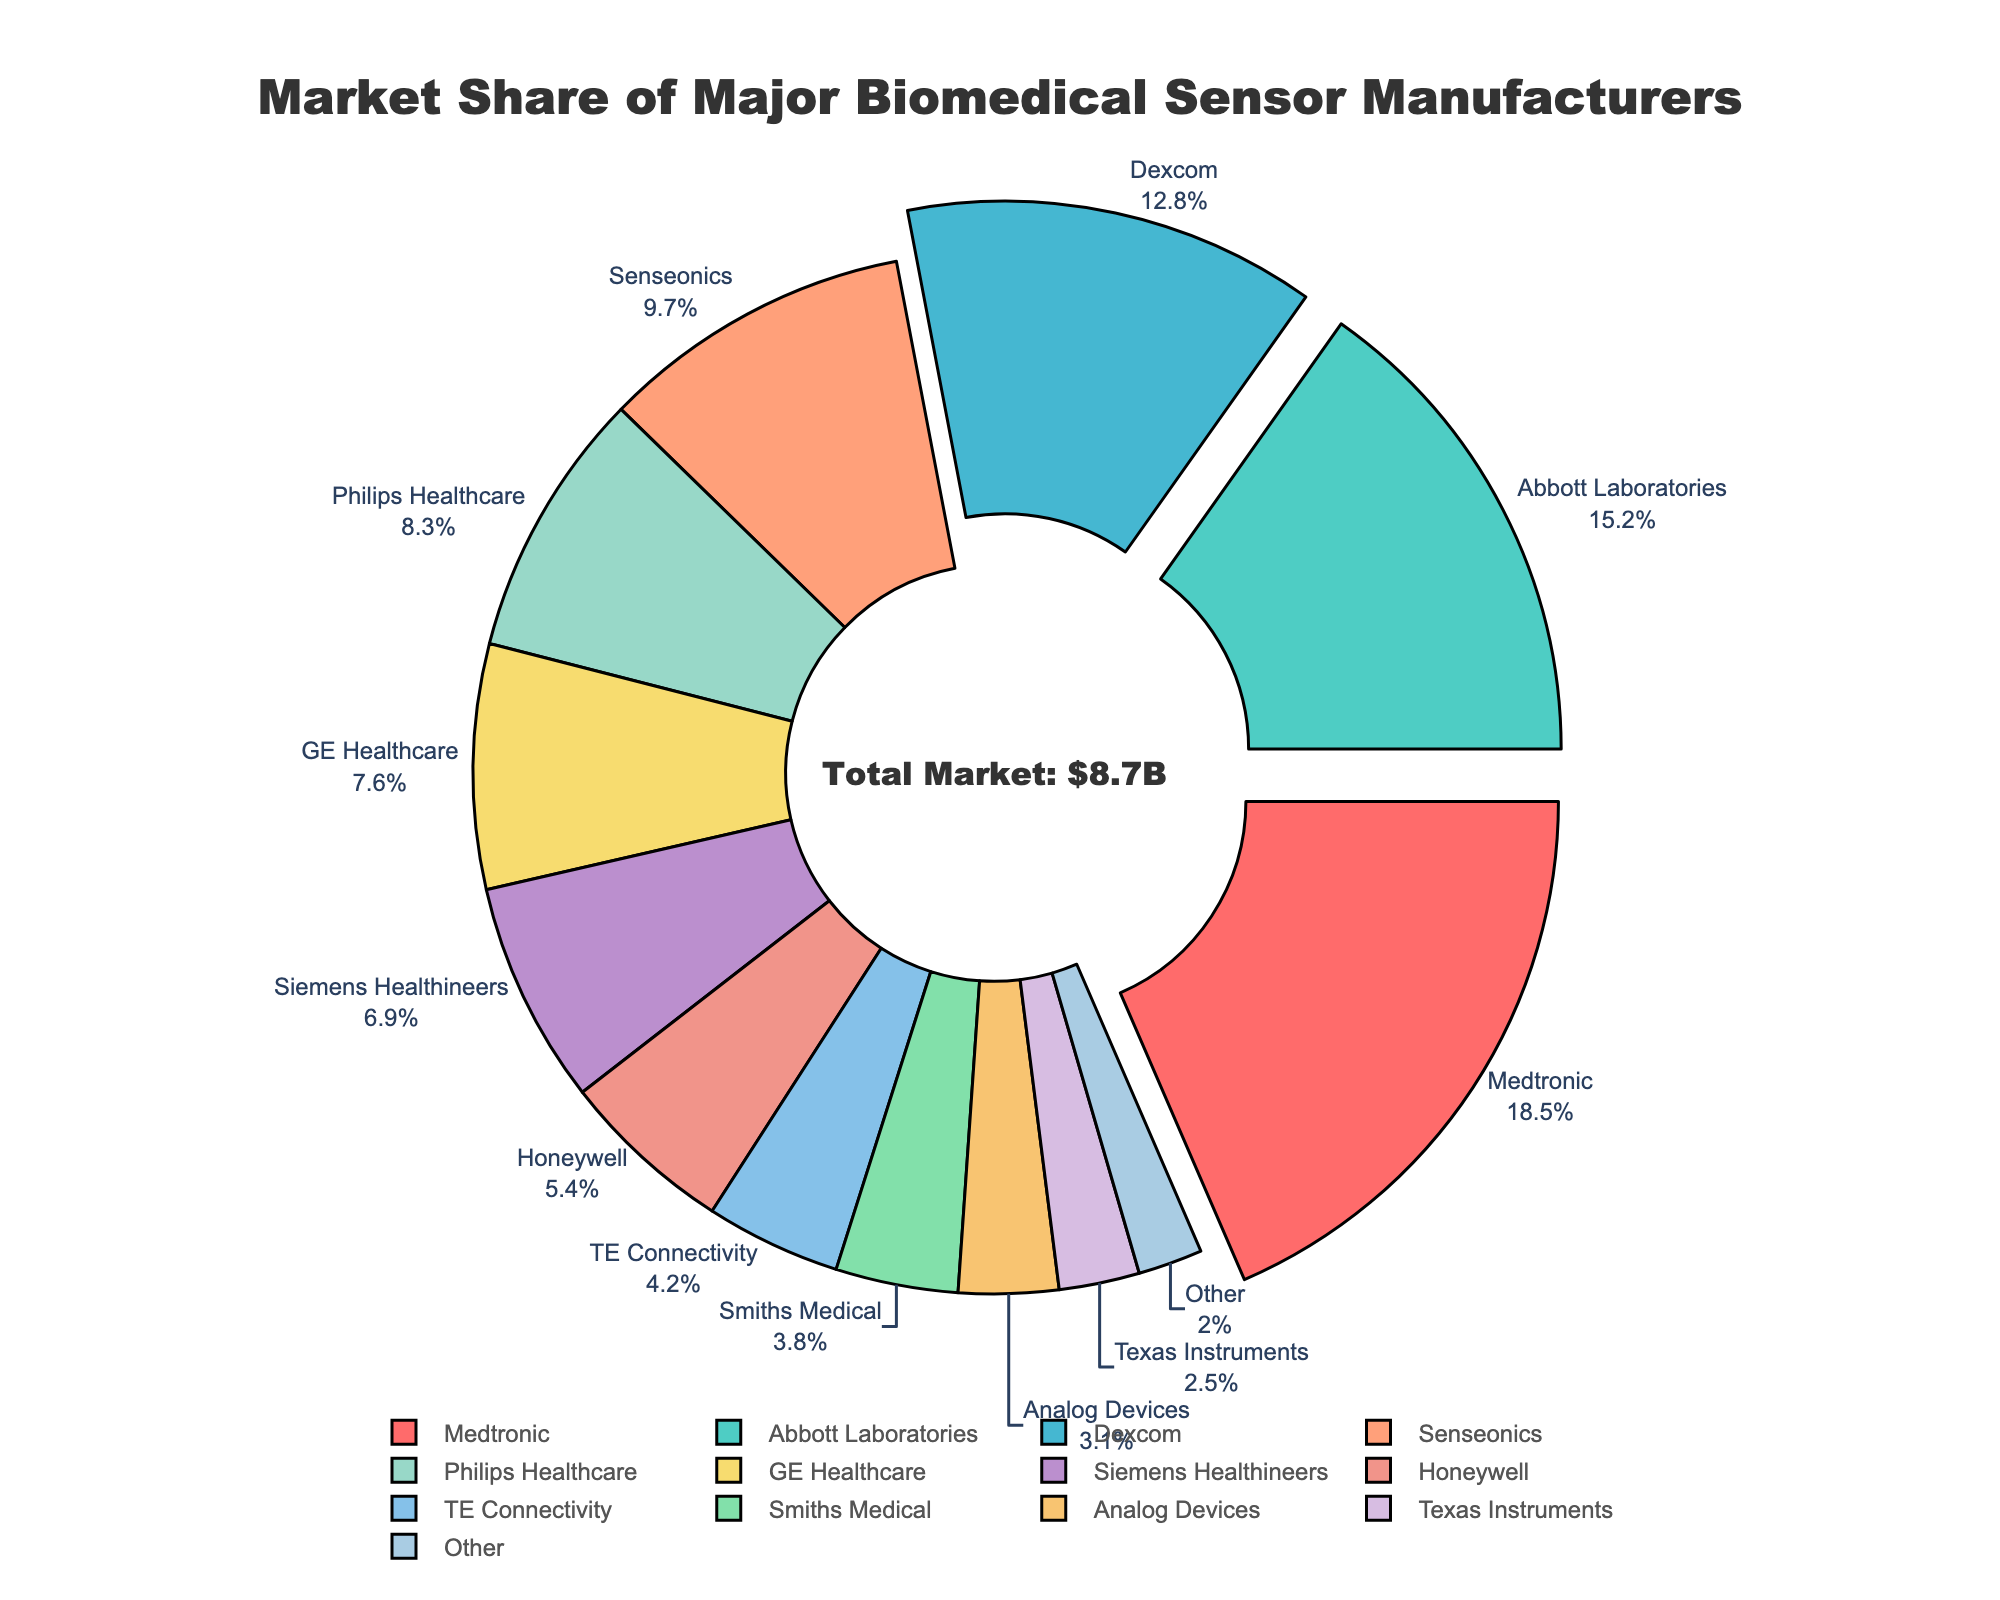What is the market share of the company with the highest market share? The company with the highest market share is Medtronic, as it has a market share of 18.5%, which is greater than any other company's share.
Answer: 18.5% Which company has the smallest market share among the top three? The top three companies in market share are Medtronic (18.5%), Abbott Laboratories (15.2%), and Dexcom (12.8%). The smallest market share among these is Dexcom's 12.8%.
Answer: Dexcom What is the combined market share of Philips Healthcare and GE Healthcare? Philips Healthcare has a market share of 8.3%, and GE Healthcare has a market share of 7.6%. Summing these up: 8.3% + 7.6% = 15.9%.
Answer: 15.9% Which two companies have a combined market share greater than 20% but less than 30%? Looking at the data, Abbott Laboratories (15.2%) and Dexcom (12.8%) combined make 28%, which fits the criteria of being greater than 20% but less than 30%.
Answer: Abbott Laboratories and Dexcom What percentage of the market is held by companies with less than 5% share individually? Companies with less than 5% share are TE Connectivity (4.2%), Smiths Medical (3.8%), Analog Devices (3.1%), Texas Instruments (2.5%), and Other (2.0%). Summing them: 4.2% + 3.8% + 3.1% + 2.5% + 2.0% = 15.6%.
Answer: 15.6% Which manufacturers have their shares highlighted or pulled out in the pie chart, and why? The manufacturers with market shares greater than 10%, namely Medtronic, Abbott Laboratories, and Dexcom, have their sections pulled out, which highlights their significant market shares.
Answer: Medtronic, Abbott Laboratories, and Dexcom What is the color of the section representing Senseonics? Senseonics is represented with the green color in the pie chart.
Answer: Green Of the companies listed, which one has a market share closest to the average market share of all companies? First, calculate the average market share: (18.5 + 15.2 + 12.8 + 9.7 + 8.3 + 7.6 + 6.9 + 5.4 + 4.2 + 3.8 + 3.1 + 2.5 + 2.0) / 13 ≈ 7.69%. Given this, the company closest to this average is Siemens Healthineers with 6.9%.
Answer: Siemens Healthineers 